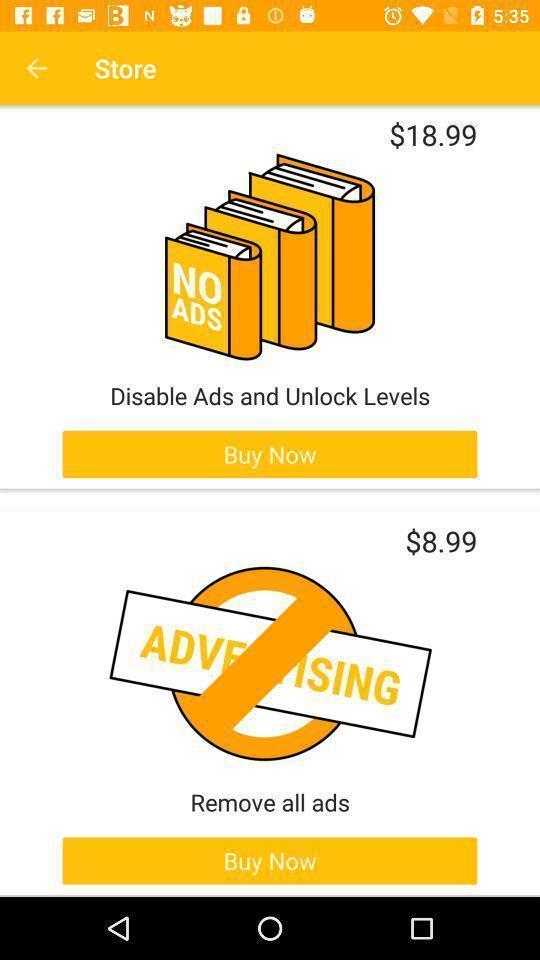Describe the visual elements of this screenshot. Screen displaying unlock levels with buy now option. 